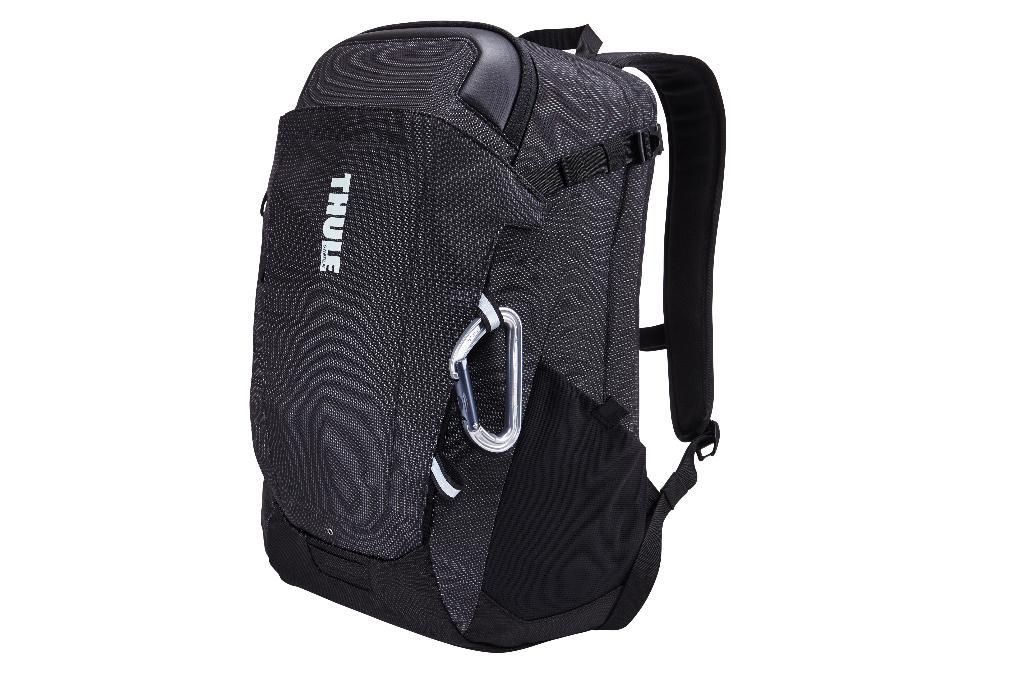What is the color of the bag in the image? The bag in the image is black in color. What is the color of the background in the image? The background of the image is white in color. How many slaves are visible in the image? There are no slaves present in the image. What type of pie is being served in the image? There is no pie present in the image. 